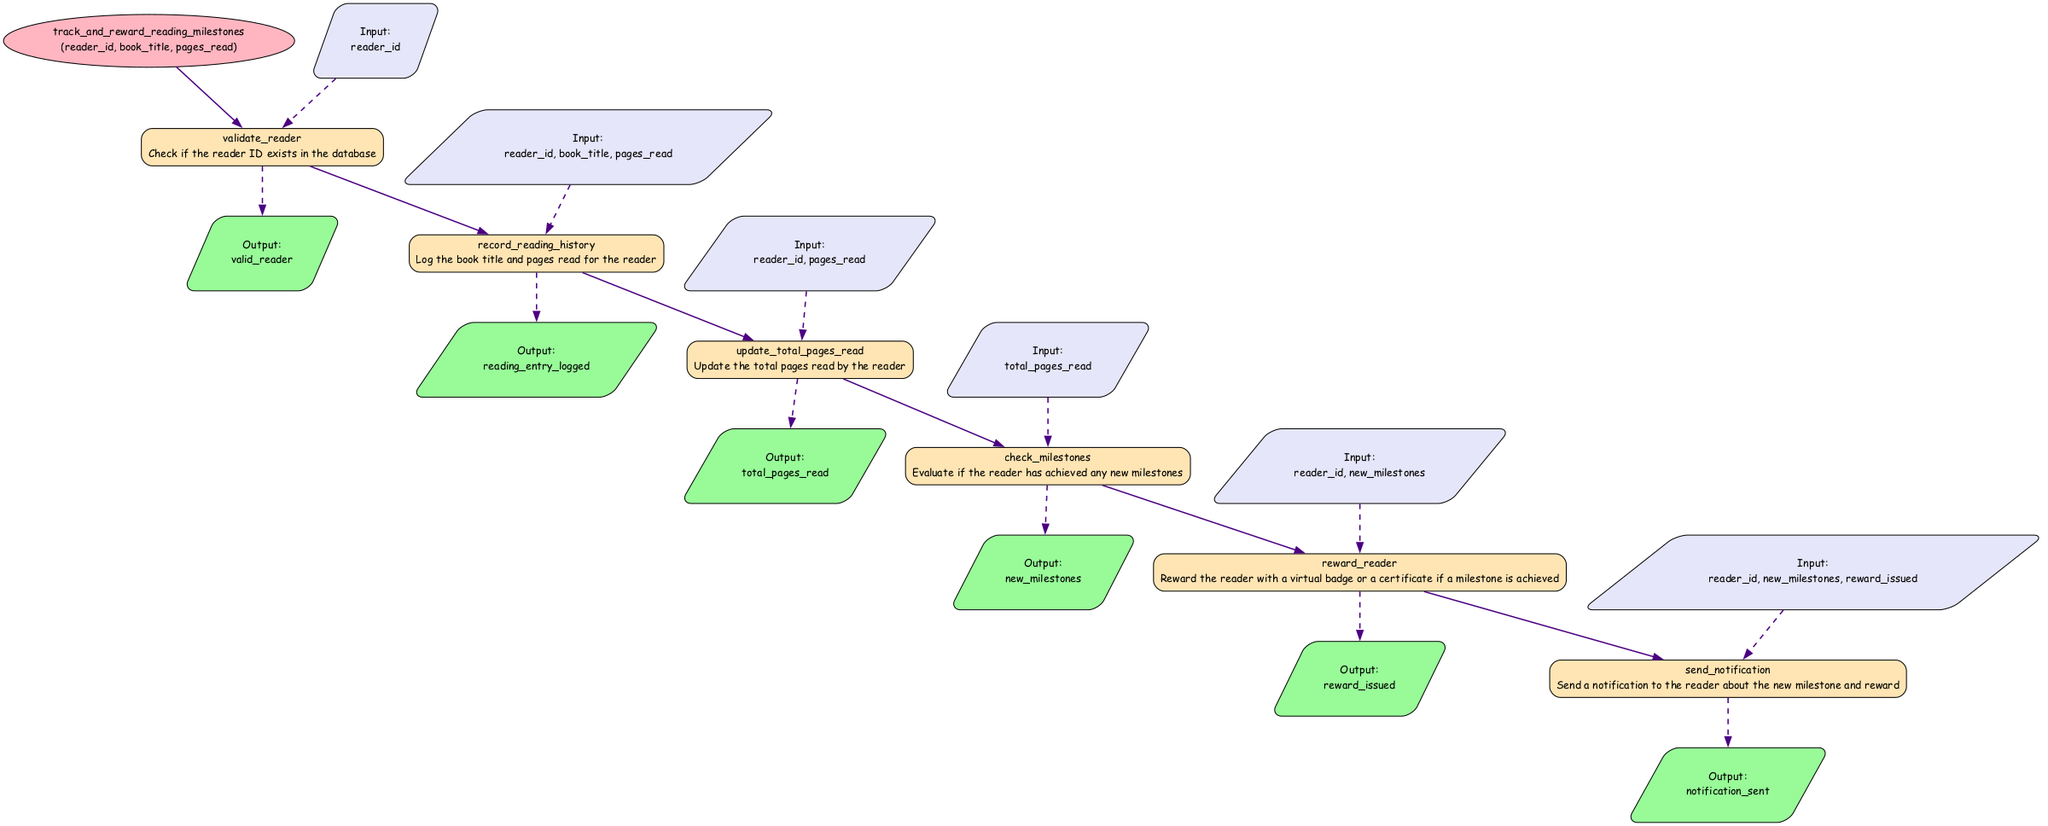What is the name of the function in the diagram? The function's name is specified at the top of the diagram within the ellipse node labeled "function". It states "track_and_reward_reading_milestones".
Answer: track and reward reading milestones How many parameters does the function have? The parameters are listed next to the function name. There are three parameters: "reader_id", "book_title", and "pages_read". Counting these gives a total of three.
Answer: 3 What is the action of the "validate_reader" element? The action associated with the "validate_reader" element is provided in the description under the respective node, which states "Check if the reader ID exists in the database".
Answer: Check if the reader ID exists in the database How many output nodes are in the diagram? Each element has one output node, and there are six elements listed in the diagram. Therefore, there are six output nodes present.
Answer: 6 What is the output of the "reward_reader" element? Under the "reward_reader" node, the output is listed as "reward_issued". This indicates the outcome of that process, which can be found directly alongside the element's description.
Answer: reward issued What is the last element that follows the processing of "update_total_pages_read"? Following the "update_total_pages_read" node in the flow, the next element is "check_milestones". This information is determined by examining the directed flow of arrows in the diagram.
Answer: check milestones What inputs does the "send_notification" element require? The inputs needed for the "send_notification" element are presented under the respective node. They are "reader_id", "new_milestones", and "reward_issued".
Answer: reader ID, new milestones, reward issued Which element issues a reward to the reader? The element that handles issuing a reward is clearly labeled as "reward_reader" in the diagram, which specifically mentions rewarding the reader for achieved milestones.
Answer: reward reader What is the relationship between "check_milestones" and "reward_reader"? The relationship is one of output and input; "check_milestones" outputs "new_milestones", which serves as an input to "reward_reader". This illustrates a sequential dependency in the flowchart.
Answer: new milestones to reward reader 